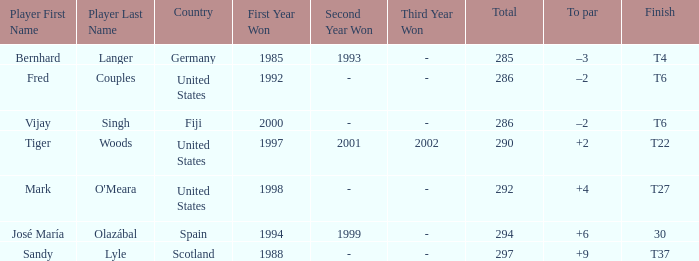Which player has +2 to par? Tiger Woods. 